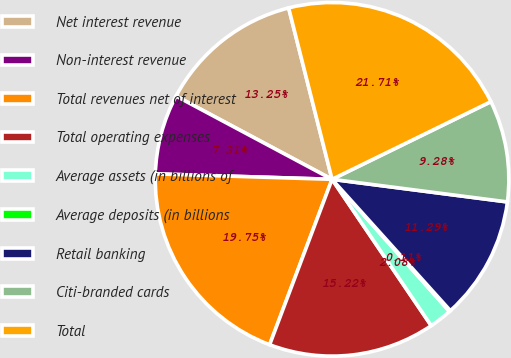Convert chart to OTSL. <chart><loc_0><loc_0><loc_500><loc_500><pie_chart><fcel>Net interest revenue<fcel>Non-interest revenue<fcel>Total revenues net of interest<fcel>Total operating expenses<fcel>Average assets (in billions of<fcel>Average deposits (in billions<fcel>Retail banking<fcel>Citi-branded cards<fcel>Total<nl><fcel>13.25%<fcel>7.31%<fcel>19.75%<fcel>15.22%<fcel>2.08%<fcel>0.11%<fcel>11.29%<fcel>9.28%<fcel>21.71%<nl></chart> 